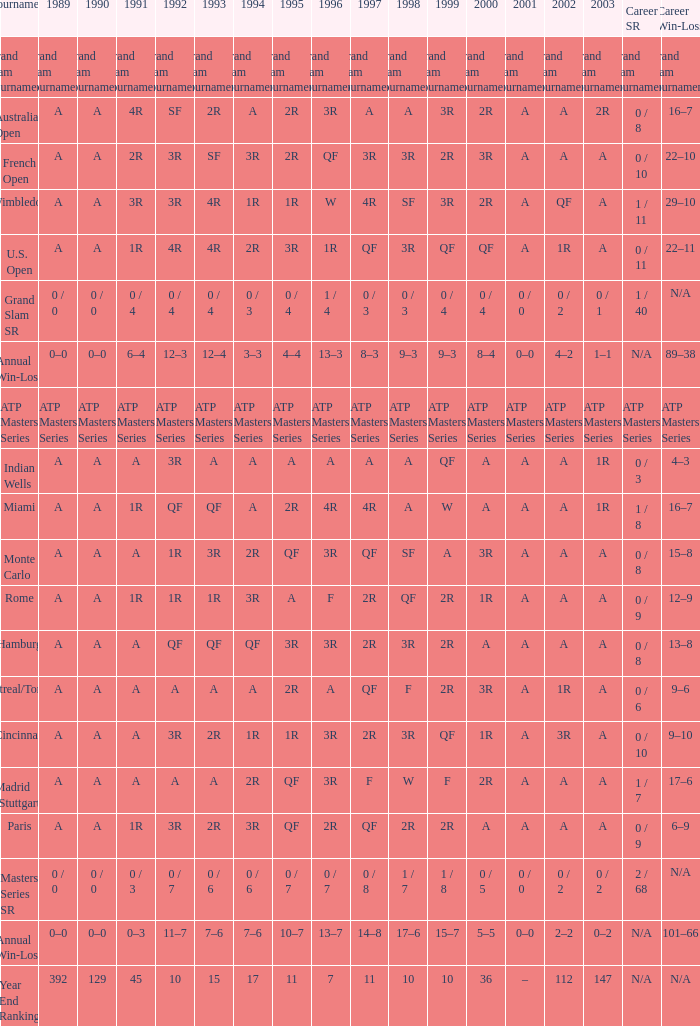What is the worth in 1997 when the worth in 1989 is a, 1995 is qf, 1996 is 3r and the career sr is 0 / 8? QF. 